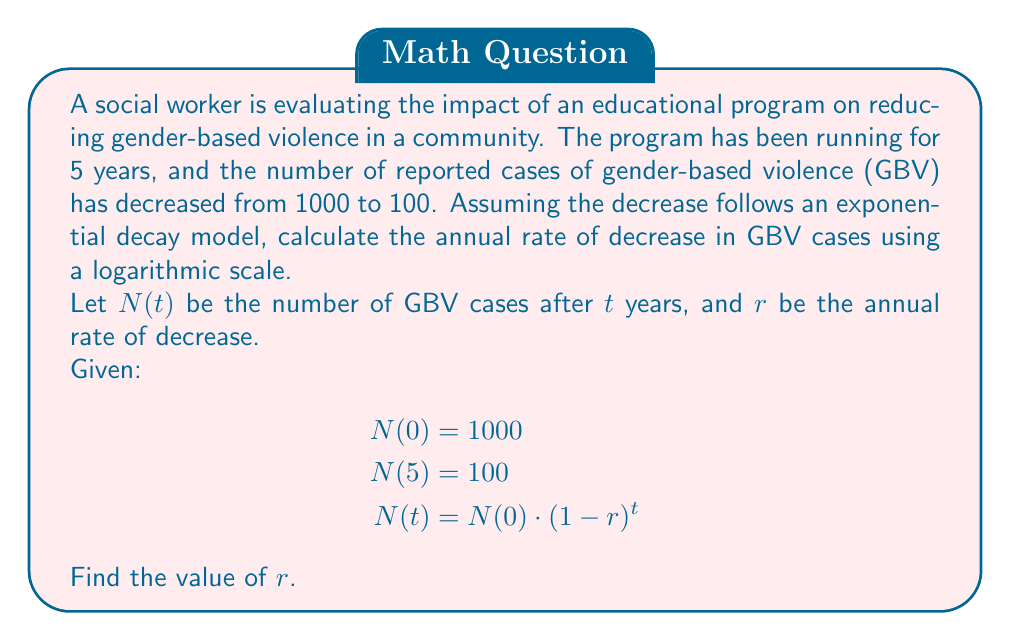Help me with this question. To solve this problem, we'll use the exponential decay model and logarithms. Let's follow these steps:

1) We start with the equation: $N(t) = N(0) \cdot (1-r)^t$

2) Substituting the known values:
   $100 = 1000 \cdot (1-r)^5$

3) Divide both sides by 1000:
   $\frac{1}{10} = (1-r)^5$

4) Take the natural logarithm of both sides:
   $\ln(\frac{1}{10}) = \ln((1-r)^5)$

5) Use the logarithm property $\ln(a^b) = b\ln(a)$:
   $\ln(\frac{1}{10}) = 5\ln(1-r)$

6) Simplify the left side:
   $-\ln(10) = 5\ln(1-r)$

7) Divide both sides by 5:
   $-\frac{\ln(10)}{5} = \ln(1-r)$

8) Take the exponential of both sides:
   $e^{-\frac{\ln(10)}{5}} = 1-r$

9) Subtract from 1 on both sides:
   $1 - e^{-\frac{\ln(10)}{5}} = r$

10) Calculate the final value:
    $r = 1 - e^{-\frac{\ln(10)}{5}} \approx 0.3697$ or about 36.97%

This means the annual rate of decrease in GBV cases is approximately 36.97%.
Answer: $r \approx 0.3697$ or 36.97% 